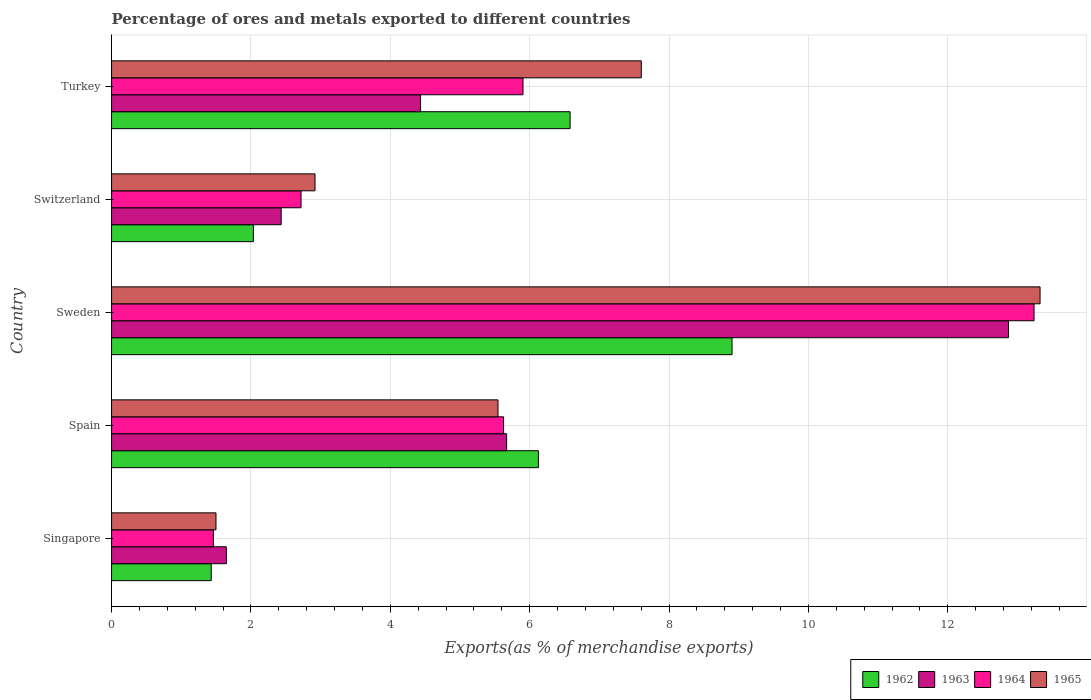How many different coloured bars are there?
Make the answer very short. 4. Are the number of bars on each tick of the Y-axis equal?
Offer a very short reply. Yes. How many bars are there on the 5th tick from the top?
Provide a short and direct response. 4. How many bars are there on the 5th tick from the bottom?
Give a very brief answer. 4. What is the label of the 4th group of bars from the top?
Your answer should be very brief. Spain. What is the percentage of exports to different countries in 1965 in Singapore?
Offer a very short reply. 1.5. Across all countries, what is the maximum percentage of exports to different countries in 1963?
Offer a terse response. 12.87. Across all countries, what is the minimum percentage of exports to different countries in 1963?
Your answer should be compact. 1.65. In which country was the percentage of exports to different countries in 1962 maximum?
Your answer should be very brief. Sweden. In which country was the percentage of exports to different countries in 1964 minimum?
Make the answer very short. Singapore. What is the total percentage of exports to different countries in 1962 in the graph?
Your answer should be compact. 25.07. What is the difference between the percentage of exports to different countries in 1964 in Singapore and that in Spain?
Make the answer very short. -4.16. What is the difference between the percentage of exports to different countries in 1965 in Sweden and the percentage of exports to different countries in 1964 in Spain?
Offer a terse response. 7.7. What is the average percentage of exports to different countries in 1964 per country?
Provide a short and direct response. 5.79. What is the difference between the percentage of exports to different countries in 1964 and percentage of exports to different countries in 1963 in Spain?
Offer a very short reply. -0.04. What is the ratio of the percentage of exports to different countries in 1962 in Singapore to that in Switzerland?
Your answer should be compact. 0.7. Is the percentage of exports to different countries in 1962 in Sweden less than that in Switzerland?
Make the answer very short. No. Is the difference between the percentage of exports to different countries in 1964 in Spain and Sweden greater than the difference between the percentage of exports to different countries in 1963 in Spain and Sweden?
Your response must be concise. No. What is the difference between the highest and the second highest percentage of exports to different countries in 1964?
Give a very brief answer. 7.33. What is the difference between the highest and the lowest percentage of exports to different countries in 1964?
Give a very brief answer. 11.78. In how many countries, is the percentage of exports to different countries in 1965 greater than the average percentage of exports to different countries in 1965 taken over all countries?
Give a very brief answer. 2. Is it the case that in every country, the sum of the percentage of exports to different countries in 1963 and percentage of exports to different countries in 1965 is greater than the percentage of exports to different countries in 1964?
Keep it short and to the point. Yes. Does the graph contain grids?
Provide a short and direct response. Yes. Where does the legend appear in the graph?
Provide a succinct answer. Bottom right. What is the title of the graph?
Give a very brief answer. Percentage of ores and metals exported to different countries. What is the label or title of the X-axis?
Your answer should be compact. Exports(as % of merchandise exports). What is the label or title of the Y-axis?
Your answer should be very brief. Country. What is the Exports(as % of merchandise exports) of 1962 in Singapore?
Ensure brevity in your answer.  1.43. What is the Exports(as % of merchandise exports) in 1963 in Singapore?
Provide a short and direct response. 1.65. What is the Exports(as % of merchandise exports) in 1964 in Singapore?
Your answer should be very brief. 1.46. What is the Exports(as % of merchandise exports) of 1965 in Singapore?
Provide a succinct answer. 1.5. What is the Exports(as % of merchandise exports) in 1962 in Spain?
Give a very brief answer. 6.13. What is the Exports(as % of merchandise exports) in 1963 in Spain?
Your answer should be very brief. 5.67. What is the Exports(as % of merchandise exports) of 1964 in Spain?
Your answer should be compact. 5.63. What is the Exports(as % of merchandise exports) in 1965 in Spain?
Your answer should be very brief. 5.55. What is the Exports(as % of merchandise exports) in 1962 in Sweden?
Offer a terse response. 8.9. What is the Exports(as % of merchandise exports) of 1963 in Sweden?
Ensure brevity in your answer.  12.87. What is the Exports(as % of merchandise exports) in 1964 in Sweden?
Your response must be concise. 13.24. What is the Exports(as % of merchandise exports) in 1965 in Sweden?
Your answer should be compact. 13.32. What is the Exports(as % of merchandise exports) of 1962 in Switzerland?
Ensure brevity in your answer.  2.03. What is the Exports(as % of merchandise exports) of 1963 in Switzerland?
Offer a very short reply. 2.43. What is the Exports(as % of merchandise exports) of 1964 in Switzerland?
Provide a succinct answer. 2.72. What is the Exports(as % of merchandise exports) of 1965 in Switzerland?
Make the answer very short. 2.92. What is the Exports(as % of merchandise exports) of 1962 in Turkey?
Your answer should be compact. 6.58. What is the Exports(as % of merchandise exports) in 1963 in Turkey?
Give a very brief answer. 4.43. What is the Exports(as % of merchandise exports) in 1964 in Turkey?
Give a very brief answer. 5.9. What is the Exports(as % of merchandise exports) in 1965 in Turkey?
Provide a short and direct response. 7.6. Across all countries, what is the maximum Exports(as % of merchandise exports) of 1962?
Ensure brevity in your answer.  8.9. Across all countries, what is the maximum Exports(as % of merchandise exports) of 1963?
Your response must be concise. 12.87. Across all countries, what is the maximum Exports(as % of merchandise exports) in 1964?
Provide a short and direct response. 13.24. Across all countries, what is the maximum Exports(as % of merchandise exports) in 1965?
Your response must be concise. 13.32. Across all countries, what is the minimum Exports(as % of merchandise exports) of 1962?
Your response must be concise. 1.43. Across all countries, what is the minimum Exports(as % of merchandise exports) of 1963?
Offer a terse response. 1.65. Across all countries, what is the minimum Exports(as % of merchandise exports) in 1964?
Provide a succinct answer. 1.46. Across all countries, what is the minimum Exports(as % of merchandise exports) in 1965?
Make the answer very short. 1.5. What is the total Exports(as % of merchandise exports) in 1962 in the graph?
Offer a very short reply. 25.07. What is the total Exports(as % of merchandise exports) in 1963 in the graph?
Your answer should be very brief. 27.06. What is the total Exports(as % of merchandise exports) of 1964 in the graph?
Offer a terse response. 28.95. What is the total Exports(as % of merchandise exports) in 1965 in the graph?
Your answer should be compact. 30.89. What is the difference between the Exports(as % of merchandise exports) of 1962 in Singapore and that in Spain?
Offer a terse response. -4.69. What is the difference between the Exports(as % of merchandise exports) in 1963 in Singapore and that in Spain?
Provide a succinct answer. -4.02. What is the difference between the Exports(as % of merchandise exports) of 1964 in Singapore and that in Spain?
Offer a terse response. -4.16. What is the difference between the Exports(as % of merchandise exports) of 1965 in Singapore and that in Spain?
Your answer should be very brief. -4.05. What is the difference between the Exports(as % of merchandise exports) of 1962 in Singapore and that in Sweden?
Your answer should be very brief. -7.47. What is the difference between the Exports(as % of merchandise exports) of 1963 in Singapore and that in Sweden?
Provide a short and direct response. -11.22. What is the difference between the Exports(as % of merchandise exports) in 1964 in Singapore and that in Sweden?
Your answer should be compact. -11.78. What is the difference between the Exports(as % of merchandise exports) of 1965 in Singapore and that in Sweden?
Make the answer very short. -11.83. What is the difference between the Exports(as % of merchandise exports) in 1962 in Singapore and that in Switzerland?
Provide a succinct answer. -0.6. What is the difference between the Exports(as % of merchandise exports) of 1963 in Singapore and that in Switzerland?
Your answer should be compact. -0.79. What is the difference between the Exports(as % of merchandise exports) in 1964 in Singapore and that in Switzerland?
Your answer should be very brief. -1.26. What is the difference between the Exports(as % of merchandise exports) of 1965 in Singapore and that in Switzerland?
Your answer should be compact. -1.42. What is the difference between the Exports(as % of merchandise exports) of 1962 in Singapore and that in Turkey?
Provide a short and direct response. -5.15. What is the difference between the Exports(as % of merchandise exports) of 1963 in Singapore and that in Turkey?
Make the answer very short. -2.79. What is the difference between the Exports(as % of merchandise exports) of 1964 in Singapore and that in Turkey?
Your answer should be compact. -4.44. What is the difference between the Exports(as % of merchandise exports) in 1965 in Singapore and that in Turkey?
Offer a very short reply. -6.1. What is the difference between the Exports(as % of merchandise exports) of 1962 in Spain and that in Sweden?
Your answer should be compact. -2.78. What is the difference between the Exports(as % of merchandise exports) of 1963 in Spain and that in Sweden?
Give a very brief answer. -7.2. What is the difference between the Exports(as % of merchandise exports) in 1964 in Spain and that in Sweden?
Your answer should be very brief. -7.61. What is the difference between the Exports(as % of merchandise exports) of 1965 in Spain and that in Sweden?
Your response must be concise. -7.78. What is the difference between the Exports(as % of merchandise exports) of 1962 in Spain and that in Switzerland?
Provide a succinct answer. 4.09. What is the difference between the Exports(as % of merchandise exports) of 1963 in Spain and that in Switzerland?
Offer a very short reply. 3.24. What is the difference between the Exports(as % of merchandise exports) of 1964 in Spain and that in Switzerland?
Give a very brief answer. 2.91. What is the difference between the Exports(as % of merchandise exports) of 1965 in Spain and that in Switzerland?
Your answer should be compact. 2.63. What is the difference between the Exports(as % of merchandise exports) in 1962 in Spain and that in Turkey?
Keep it short and to the point. -0.46. What is the difference between the Exports(as % of merchandise exports) in 1963 in Spain and that in Turkey?
Offer a terse response. 1.23. What is the difference between the Exports(as % of merchandise exports) in 1964 in Spain and that in Turkey?
Provide a short and direct response. -0.28. What is the difference between the Exports(as % of merchandise exports) in 1965 in Spain and that in Turkey?
Your answer should be very brief. -2.06. What is the difference between the Exports(as % of merchandise exports) of 1962 in Sweden and that in Switzerland?
Make the answer very short. 6.87. What is the difference between the Exports(as % of merchandise exports) in 1963 in Sweden and that in Switzerland?
Offer a very short reply. 10.44. What is the difference between the Exports(as % of merchandise exports) of 1964 in Sweden and that in Switzerland?
Provide a succinct answer. 10.52. What is the difference between the Exports(as % of merchandise exports) in 1965 in Sweden and that in Switzerland?
Your answer should be compact. 10.4. What is the difference between the Exports(as % of merchandise exports) in 1962 in Sweden and that in Turkey?
Offer a terse response. 2.32. What is the difference between the Exports(as % of merchandise exports) of 1963 in Sweden and that in Turkey?
Offer a very short reply. 8.44. What is the difference between the Exports(as % of merchandise exports) of 1964 in Sweden and that in Turkey?
Provide a short and direct response. 7.33. What is the difference between the Exports(as % of merchandise exports) in 1965 in Sweden and that in Turkey?
Keep it short and to the point. 5.72. What is the difference between the Exports(as % of merchandise exports) in 1962 in Switzerland and that in Turkey?
Keep it short and to the point. -4.55. What is the difference between the Exports(as % of merchandise exports) in 1963 in Switzerland and that in Turkey?
Make the answer very short. -2. What is the difference between the Exports(as % of merchandise exports) of 1964 in Switzerland and that in Turkey?
Your response must be concise. -3.19. What is the difference between the Exports(as % of merchandise exports) of 1965 in Switzerland and that in Turkey?
Offer a very short reply. -4.68. What is the difference between the Exports(as % of merchandise exports) in 1962 in Singapore and the Exports(as % of merchandise exports) in 1963 in Spain?
Offer a terse response. -4.24. What is the difference between the Exports(as % of merchandise exports) in 1962 in Singapore and the Exports(as % of merchandise exports) in 1964 in Spain?
Your response must be concise. -4.2. What is the difference between the Exports(as % of merchandise exports) in 1962 in Singapore and the Exports(as % of merchandise exports) in 1965 in Spain?
Provide a short and direct response. -4.11. What is the difference between the Exports(as % of merchandise exports) of 1963 in Singapore and the Exports(as % of merchandise exports) of 1964 in Spain?
Make the answer very short. -3.98. What is the difference between the Exports(as % of merchandise exports) in 1963 in Singapore and the Exports(as % of merchandise exports) in 1965 in Spain?
Make the answer very short. -3.9. What is the difference between the Exports(as % of merchandise exports) of 1964 in Singapore and the Exports(as % of merchandise exports) of 1965 in Spain?
Your response must be concise. -4.08. What is the difference between the Exports(as % of merchandise exports) in 1962 in Singapore and the Exports(as % of merchandise exports) in 1963 in Sweden?
Your response must be concise. -11.44. What is the difference between the Exports(as % of merchandise exports) of 1962 in Singapore and the Exports(as % of merchandise exports) of 1964 in Sweden?
Your answer should be compact. -11.81. What is the difference between the Exports(as % of merchandise exports) in 1962 in Singapore and the Exports(as % of merchandise exports) in 1965 in Sweden?
Offer a very short reply. -11.89. What is the difference between the Exports(as % of merchandise exports) in 1963 in Singapore and the Exports(as % of merchandise exports) in 1964 in Sweden?
Your response must be concise. -11.59. What is the difference between the Exports(as % of merchandise exports) in 1963 in Singapore and the Exports(as % of merchandise exports) in 1965 in Sweden?
Give a very brief answer. -11.68. What is the difference between the Exports(as % of merchandise exports) of 1964 in Singapore and the Exports(as % of merchandise exports) of 1965 in Sweden?
Provide a succinct answer. -11.86. What is the difference between the Exports(as % of merchandise exports) of 1962 in Singapore and the Exports(as % of merchandise exports) of 1963 in Switzerland?
Provide a short and direct response. -1. What is the difference between the Exports(as % of merchandise exports) in 1962 in Singapore and the Exports(as % of merchandise exports) in 1964 in Switzerland?
Your answer should be compact. -1.29. What is the difference between the Exports(as % of merchandise exports) in 1962 in Singapore and the Exports(as % of merchandise exports) in 1965 in Switzerland?
Your answer should be compact. -1.49. What is the difference between the Exports(as % of merchandise exports) of 1963 in Singapore and the Exports(as % of merchandise exports) of 1964 in Switzerland?
Provide a succinct answer. -1.07. What is the difference between the Exports(as % of merchandise exports) in 1963 in Singapore and the Exports(as % of merchandise exports) in 1965 in Switzerland?
Keep it short and to the point. -1.27. What is the difference between the Exports(as % of merchandise exports) of 1964 in Singapore and the Exports(as % of merchandise exports) of 1965 in Switzerland?
Your answer should be very brief. -1.46. What is the difference between the Exports(as % of merchandise exports) of 1962 in Singapore and the Exports(as % of merchandise exports) of 1963 in Turkey?
Make the answer very short. -3. What is the difference between the Exports(as % of merchandise exports) of 1962 in Singapore and the Exports(as % of merchandise exports) of 1964 in Turkey?
Your answer should be very brief. -4.47. What is the difference between the Exports(as % of merchandise exports) of 1962 in Singapore and the Exports(as % of merchandise exports) of 1965 in Turkey?
Give a very brief answer. -6.17. What is the difference between the Exports(as % of merchandise exports) of 1963 in Singapore and the Exports(as % of merchandise exports) of 1964 in Turkey?
Offer a terse response. -4.26. What is the difference between the Exports(as % of merchandise exports) in 1963 in Singapore and the Exports(as % of merchandise exports) in 1965 in Turkey?
Provide a short and direct response. -5.95. What is the difference between the Exports(as % of merchandise exports) of 1964 in Singapore and the Exports(as % of merchandise exports) of 1965 in Turkey?
Ensure brevity in your answer.  -6.14. What is the difference between the Exports(as % of merchandise exports) of 1962 in Spain and the Exports(as % of merchandise exports) of 1963 in Sweden?
Make the answer very short. -6.75. What is the difference between the Exports(as % of merchandise exports) of 1962 in Spain and the Exports(as % of merchandise exports) of 1964 in Sweden?
Offer a very short reply. -7.11. What is the difference between the Exports(as % of merchandise exports) in 1962 in Spain and the Exports(as % of merchandise exports) in 1965 in Sweden?
Provide a short and direct response. -7.2. What is the difference between the Exports(as % of merchandise exports) in 1963 in Spain and the Exports(as % of merchandise exports) in 1964 in Sweden?
Make the answer very short. -7.57. What is the difference between the Exports(as % of merchandise exports) in 1963 in Spain and the Exports(as % of merchandise exports) in 1965 in Sweden?
Offer a terse response. -7.65. What is the difference between the Exports(as % of merchandise exports) of 1964 in Spain and the Exports(as % of merchandise exports) of 1965 in Sweden?
Keep it short and to the point. -7.7. What is the difference between the Exports(as % of merchandise exports) in 1962 in Spain and the Exports(as % of merchandise exports) in 1963 in Switzerland?
Make the answer very short. 3.69. What is the difference between the Exports(as % of merchandise exports) in 1962 in Spain and the Exports(as % of merchandise exports) in 1964 in Switzerland?
Make the answer very short. 3.41. What is the difference between the Exports(as % of merchandise exports) of 1962 in Spain and the Exports(as % of merchandise exports) of 1965 in Switzerland?
Your response must be concise. 3.21. What is the difference between the Exports(as % of merchandise exports) in 1963 in Spain and the Exports(as % of merchandise exports) in 1964 in Switzerland?
Give a very brief answer. 2.95. What is the difference between the Exports(as % of merchandise exports) of 1963 in Spain and the Exports(as % of merchandise exports) of 1965 in Switzerland?
Keep it short and to the point. 2.75. What is the difference between the Exports(as % of merchandise exports) in 1964 in Spain and the Exports(as % of merchandise exports) in 1965 in Switzerland?
Your response must be concise. 2.71. What is the difference between the Exports(as % of merchandise exports) of 1962 in Spain and the Exports(as % of merchandise exports) of 1963 in Turkey?
Your response must be concise. 1.69. What is the difference between the Exports(as % of merchandise exports) in 1962 in Spain and the Exports(as % of merchandise exports) in 1964 in Turkey?
Ensure brevity in your answer.  0.22. What is the difference between the Exports(as % of merchandise exports) in 1962 in Spain and the Exports(as % of merchandise exports) in 1965 in Turkey?
Provide a succinct answer. -1.48. What is the difference between the Exports(as % of merchandise exports) of 1963 in Spain and the Exports(as % of merchandise exports) of 1964 in Turkey?
Your answer should be very brief. -0.23. What is the difference between the Exports(as % of merchandise exports) of 1963 in Spain and the Exports(as % of merchandise exports) of 1965 in Turkey?
Your answer should be compact. -1.93. What is the difference between the Exports(as % of merchandise exports) of 1964 in Spain and the Exports(as % of merchandise exports) of 1965 in Turkey?
Make the answer very short. -1.98. What is the difference between the Exports(as % of merchandise exports) in 1962 in Sweden and the Exports(as % of merchandise exports) in 1963 in Switzerland?
Offer a very short reply. 6.47. What is the difference between the Exports(as % of merchandise exports) of 1962 in Sweden and the Exports(as % of merchandise exports) of 1964 in Switzerland?
Provide a succinct answer. 6.18. What is the difference between the Exports(as % of merchandise exports) in 1962 in Sweden and the Exports(as % of merchandise exports) in 1965 in Switzerland?
Keep it short and to the point. 5.98. What is the difference between the Exports(as % of merchandise exports) in 1963 in Sweden and the Exports(as % of merchandise exports) in 1964 in Switzerland?
Provide a succinct answer. 10.15. What is the difference between the Exports(as % of merchandise exports) of 1963 in Sweden and the Exports(as % of merchandise exports) of 1965 in Switzerland?
Provide a succinct answer. 9.95. What is the difference between the Exports(as % of merchandise exports) in 1964 in Sweden and the Exports(as % of merchandise exports) in 1965 in Switzerland?
Give a very brief answer. 10.32. What is the difference between the Exports(as % of merchandise exports) of 1962 in Sweden and the Exports(as % of merchandise exports) of 1963 in Turkey?
Your answer should be compact. 4.47. What is the difference between the Exports(as % of merchandise exports) of 1962 in Sweden and the Exports(as % of merchandise exports) of 1964 in Turkey?
Keep it short and to the point. 3. What is the difference between the Exports(as % of merchandise exports) of 1962 in Sweden and the Exports(as % of merchandise exports) of 1965 in Turkey?
Offer a terse response. 1.3. What is the difference between the Exports(as % of merchandise exports) of 1963 in Sweden and the Exports(as % of merchandise exports) of 1964 in Turkey?
Provide a short and direct response. 6.97. What is the difference between the Exports(as % of merchandise exports) in 1963 in Sweden and the Exports(as % of merchandise exports) in 1965 in Turkey?
Provide a short and direct response. 5.27. What is the difference between the Exports(as % of merchandise exports) of 1964 in Sweden and the Exports(as % of merchandise exports) of 1965 in Turkey?
Give a very brief answer. 5.64. What is the difference between the Exports(as % of merchandise exports) in 1962 in Switzerland and the Exports(as % of merchandise exports) in 1963 in Turkey?
Your answer should be compact. -2.4. What is the difference between the Exports(as % of merchandise exports) in 1962 in Switzerland and the Exports(as % of merchandise exports) in 1964 in Turkey?
Give a very brief answer. -3.87. What is the difference between the Exports(as % of merchandise exports) in 1962 in Switzerland and the Exports(as % of merchandise exports) in 1965 in Turkey?
Offer a very short reply. -5.57. What is the difference between the Exports(as % of merchandise exports) in 1963 in Switzerland and the Exports(as % of merchandise exports) in 1964 in Turkey?
Give a very brief answer. -3.47. What is the difference between the Exports(as % of merchandise exports) in 1963 in Switzerland and the Exports(as % of merchandise exports) in 1965 in Turkey?
Offer a terse response. -5.17. What is the difference between the Exports(as % of merchandise exports) of 1964 in Switzerland and the Exports(as % of merchandise exports) of 1965 in Turkey?
Offer a very short reply. -4.88. What is the average Exports(as % of merchandise exports) of 1962 per country?
Ensure brevity in your answer.  5.01. What is the average Exports(as % of merchandise exports) in 1963 per country?
Your response must be concise. 5.41. What is the average Exports(as % of merchandise exports) of 1964 per country?
Provide a short and direct response. 5.79. What is the average Exports(as % of merchandise exports) in 1965 per country?
Your response must be concise. 6.18. What is the difference between the Exports(as % of merchandise exports) of 1962 and Exports(as % of merchandise exports) of 1963 in Singapore?
Keep it short and to the point. -0.22. What is the difference between the Exports(as % of merchandise exports) in 1962 and Exports(as % of merchandise exports) in 1964 in Singapore?
Offer a very short reply. -0.03. What is the difference between the Exports(as % of merchandise exports) of 1962 and Exports(as % of merchandise exports) of 1965 in Singapore?
Your answer should be compact. -0.07. What is the difference between the Exports(as % of merchandise exports) in 1963 and Exports(as % of merchandise exports) in 1964 in Singapore?
Make the answer very short. 0.19. What is the difference between the Exports(as % of merchandise exports) in 1963 and Exports(as % of merchandise exports) in 1965 in Singapore?
Your answer should be compact. 0.15. What is the difference between the Exports(as % of merchandise exports) of 1964 and Exports(as % of merchandise exports) of 1965 in Singapore?
Ensure brevity in your answer.  -0.04. What is the difference between the Exports(as % of merchandise exports) in 1962 and Exports(as % of merchandise exports) in 1963 in Spain?
Provide a short and direct response. 0.46. What is the difference between the Exports(as % of merchandise exports) of 1962 and Exports(as % of merchandise exports) of 1964 in Spain?
Your response must be concise. 0.5. What is the difference between the Exports(as % of merchandise exports) of 1962 and Exports(as % of merchandise exports) of 1965 in Spain?
Ensure brevity in your answer.  0.58. What is the difference between the Exports(as % of merchandise exports) in 1963 and Exports(as % of merchandise exports) in 1964 in Spain?
Ensure brevity in your answer.  0.04. What is the difference between the Exports(as % of merchandise exports) in 1963 and Exports(as % of merchandise exports) in 1965 in Spain?
Your response must be concise. 0.12. What is the difference between the Exports(as % of merchandise exports) in 1964 and Exports(as % of merchandise exports) in 1965 in Spain?
Provide a succinct answer. 0.08. What is the difference between the Exports(as % of merchandise exports) of 1962 and Exports(as % of merchandise exports) of 1963 in Sweden?
Provide a short and direct response. -3.97. What is the difference between the Exports(as % of merchandise exports) of 1962 and Exports(as % of merchandise exports) of 1964 in Sweden?
Ensure brevity in your answer.  -4.33. What is the difference between the Exports(as % of merchandise exports) of 1962 and Exports(as % of merchandise exports) of 1965 in Sweden?
Ensure brevity in your answer.  -4.42. What is the difference between the Exports(as % of merchandise exports) in 1963 and Exports(as % of merchandise exports) in 1964 in Sweden?
Keep it short and to the point. -0.37. What is the difference between the Exports(as % of merchandise exports) of 1963 and Exports(as % of merchandise exports) of 1965 in Sweden?
Provide a short and direct response. -0.45. What is the difference between the Exports(as % of merchandise exports) of 1964 and Exports(as % of merchandise exports) of 1965 in Sweden?
Offer a very short reply. -0.09. What is the difference between the Exports(as % of merchandise exports) in 1962 and Exports(as % of merchandise exports) in 1963 in Switzerland?
Give a very brief answer. -0.4. What is the difference between the Exports(as % of merchandise exports) of 1962 and Exports(as % of merchandise exports) of 1964 in Switzerland?
Make the answer very short. -0.68. What is the difference between the Exports(as % of merchandise exports) in 1962 and Exports(as % of merchandise exports) in 1965 in Switzerland?
Offer a very short reply. -0.89. What is the difference between the Exports(as % of merchandise exports) in 1963 and Exports(as % of merchandise exports) in 1964 in Switzerland?
Your answer should be very brief. -0.29. What is the difference between the Exports(as % of merchandise exports) of 1963 and Exports(as % of merchandise exports) of 1965 in Switzerland?
Provide a short and direct response. -0.49. What is the difference between the Exports(as % of merchandise exports) of 1964 and Exports(as % of merchandise exports) of 1965 in Switzerland?
Make the answer very short. -0.2. What is the difference between the Exports(as % of merchandise exports) of 1962 and Exports(as % of merchandise exports) of 1963 in Turkey?
Offer a terse response. 2.15. What is the difference between the Exports(as % of merchandise exports) in 1962 and Exports(as % of merchandise exports) in 1964 in Turkey?
Keep it short and to the point. 0.68. What is the difference between the Exports(as % of merchandise exports) in 1962 and Exports(as % of merchandise exports) in 1965 in Turkey?
Offer a very short reply. -1.02. What is the difference between the Exports(as % of merchandise exports) in 1963 and Exports(as % of merchandise exports) in 1964 in Turkey?
Provide a short and direct response. -1.47. What is the difference between the Exports(as % of merchandise exports) in 1963 and Exports(as % of merchandise exports) in 1965 in Turkey?
Offer a terse response. -3.17. What is the difference between the Exports(as % of merchandise exports) of 1964 and Exports(as % of merchandise exports) of 1965 in Turkey?
Make the answer very short. -1.7. What is the ratio of the Exports(as % of merchandise exports) in 1962 in Singapore to that in Spain?
Offer a very short reply. 0.23. What is the ratio of the Exports(as % of merchandise exports) in 1963 in Singapore to that in Spain?
Your answer should be very brief. 0.29. What is the ratio of the Exports(as % of merchandise exports) of 1964 in Singapore to that in Spain?
Provide a short and direct response. 0.26. What is the ratio of the Exports(as % of merchandise exports) of 1965 in Singapore to that in Spain?
Keep it short and to the point. 0.27. What is the ratio of the Exports(as % of merchandise exports) of 1962 in Singapore to that in Sweden?
Give a very brief answer. 0.16. What is the ratio of the Exports(as % of merchandise exports) of 1963 in Singapore to that in Sweden?
Your answer should be compact. 0.13. What is the ratio of the Exports(as % of merchandise exports) in 1964 in Singapore to that in Sweden?
Make the answer very short. 0.11. What is the ratio of the Exports(as % of merchandise exports) of 1965 in Singapore to that in Sweden?
Give a very brief answer. 0.11. What is the ratio of the Exports(as % of merchandise exports) in 1962 in Singapore to that in Switzerland?
Ensure brevity in your answer.  0.7. What is the ratio of the Exports(as % of merchandise exports) of 1963 in Singapore to that in Switzerland?
Ensure brevity in your answer.  0.68. What is the ratio of the Exports(as % of merchandise exports) of 1964 in Singapore to that in Switzerland?
Give a very brief answer. 0.54. What is the ratio of the Exports(as % of merchandise exports) of 1965 in Singapore to that in Switzerland?
Give a very brief answer. 0.51. What is the ratio of the Exports(as % of merchandise exports) in 1962 in Singapore to that in Turkey?
Ensure brevity in your answer.  0.22. What is the ratio of the Exports(as % of merchandise exports) of 1963 in Singapore to that in Turkey?
Offer a terse response. 0.37. What is the ratio of the Exports(as % of merchandise exports) of 1964 in Singapore to that in Turkey?
Ensure brevity in your answer.  0.25. What is the ratio of the Exports(as % of merchandise exports) in 1965 in Singapore to that in Turkey?
Provide a succinct answer. 0.2. What is the ratio of the Exports(as % of merchandise exports) of 1962 in Spain to that in Sweden?
Keep it short and to the point. 0.69. What is the ratio of the Exports(as % of merchandise exports) in 1963 in Spain to that in Sweden?
Offer a very short reply. 0.44. What is the ratio of the Exports(as % of merchandise exports) in 1964 in Spain to that in Sweden?
Your answer should be compact. 0.42. What is the ratio of the Exports(as % of merchandise exports) of 1965 in Spain to that in Sweden?
Offer a very short reply. 0.42. What is the ratio of the Exports(as % of merchandise exports) of 1962 in Spain to that in Switzerland?
Offer a very short reply. 3.01. What is the ratio of the Exports(as % of merchandise exports) in 1963 in Spain to that in Switzerland?
Your answer should be compact. 2.33. What is the ratio of the Exports(as % of merchandise exports) in 1964 in Spain to that in Switzerland?
Offer a terse response. 2.07. What is the ratio of the Exports(as % of merchandise exports) of 1965 in Spain to that in Switzerland?
Keep it short and to the point. 1.9. What is the ratio of the Exports(as % of merchandise exports) in 1962 in Spain to that in Turkey?
Keep it short and to the point. 0.93. What is the ratio of the Exports(as % of merchandise exports) of 1963 in Spain to that in Turkey?
Your response must be concise. 1.28. What is the ratio of the Exports(as % of merchandise exports) in 1964 in Spain to that in Turkey?
Your response must be concise. 0.95. What is the ratio of the Exports(as % of merchandise exports) in 1965 in Spain to that in Turkey?
Make the answer very short. 0.73. What is the ratio of the Exports(as % of merchandise exports) in 1962 in Sweden to that in Switzerland?
Keep it short and to the point. 4.38. What is the ratio of the Exports(as % of merchandise exports) in 1963 in Sweden to that in Switzerland?
Keep it short and to the point. 5.29. What is the ratio of the Exports(as % of merchandise exports) in 1964 in Sweden to that in Switzerland?
Make the answer very short. 4.87. What is the ratio of the Exports(as % of merchandise exports) in 1965 in Sweden to that in Switzerland?
Make the answer very short. 4.56. What is the ratio of the Exports(as % of merchandise exports) in 1962 in Sweden to that in Turkey?
Offer a very short reply. 1.35. What is the ratio of the Exports(as % of merchandise exports) in 1963 in Sweden to that in Turkey?
Give a very brief answer. 2.9. What is the ratio of the Exports(as % of merchandise exports) of 1964 in Sweden to that in Turkey?
Provide a short and direct response. 2.24. What is the ratio of the Exports(as % of merchandise exports) of 1965 in Sweden to that in Turkey?
Keep it short and to the point. 1.75. What is the ratio of the Exports(as % of merchandise exports) of 1962 in Switzerland to that in Turkey?
Provide a succinct answer. 0.31. What is the ratio of the Exports(as % of merchandise exports) of 1963 in Switzerland to that in Turkey?
Give a very brief answer. 0.55. What is the ratio of the Exports(as % of merchandise exports) of 1964 in Switzerland to that in Turkey?
Offer a terse response. 0.46. What is the ratio of the Exports(as % of merchandise exports) of 1965 in Switzerland to that in Turkey?
Give a very brief answer. 0.38. What is the difference between the highest and the second highest Exports(as % of merchandise exports) of 1962?
Offer a very short reply. 2.32. What is the difference between the highest and the second highest Exports(as % of merchandise exports) of 1963?
Make the answer very short. 7.2. What is the difference between the highest and the second highest Exports(as % of merchandise exports) in 1964?
Provide a short and direct response. 7.33. What is the difference between the highest and the second highest Exports(as % of merchandise exports) of 1965?
Ensure brevity in your answer.  5.72. What is the difference between the highest and the lowest Exports(as % of merchandise exports) in 1962?
Your answer should be compact. 7.47. What is the difference between the highest and the lowest Exports(as % of merchandise exports) in 1963?
Provide a succinct answer. 11.22. What is the difference between the highest and the lowest Exports(as % of merchandise exports) of 1964?
Ensure brevity in your answer.  11.78. What is the difference between the highest and the lowest Exports(as % of merchandise exports) in 1965?
Provide a short and direct response. 11.83. 